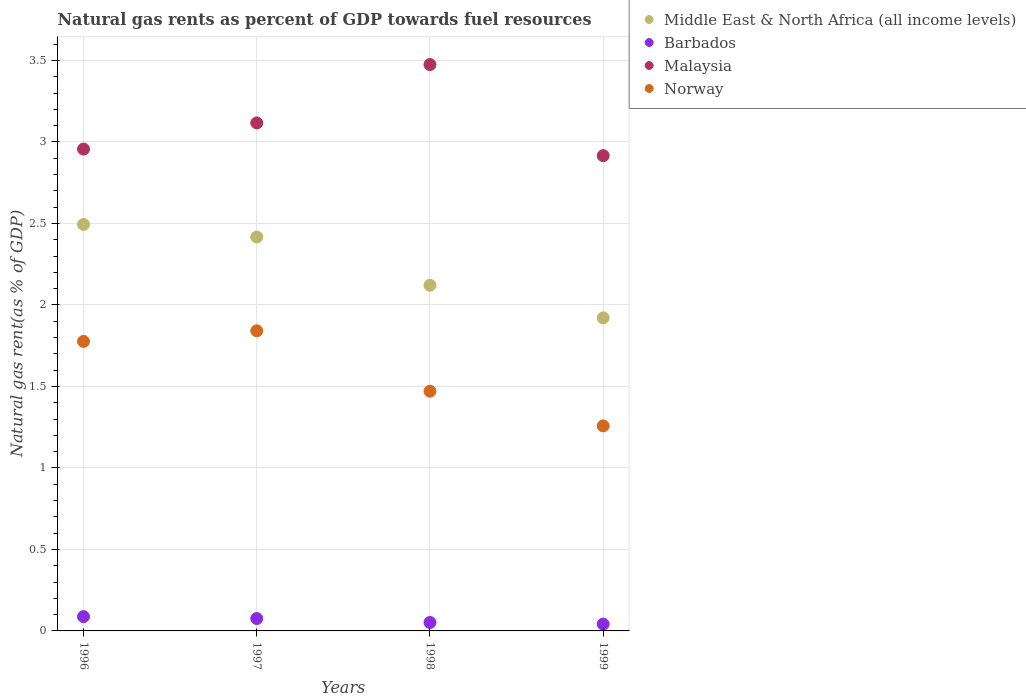Is the number of dotlines equal to the number of legend labels?
Keep it short and to the point. Yes. What is the natural gas rent in Middle East & North Africa (all income levels) in 1998?
Offer a terse response. 2.12. Across all years, what is the maximum natural gas rent in Middle East & North Africa (all income levels)?
Keep it short and to the point. 2.49. Across all years, what is the minimum natural gas rent in Barbados?
Offer a terse response. 0.04. In which year was the natural gas rent in Middle East & North Africa (all income levels) maximum?
Provide a succinct answer. 1996. What is the total natural gas rent in Barbados in the graph?
Your answer should be compact. 0.26. What is the difference between the natural gas rent in Middle East & North Africa (all income levels) in 1996 and that in 1999?
Make the answer very short. 0.57. What is the difference between the natural gas rent in Middle East & North Africa (all income levels) in 1998 and the natural gas rent in Barbados in 1999?
Provide a short and direct response. 2.08. What is the average natural gas rent in Malaysia per year?
Ensure brevity in your answer.  3.12. In the year 1996, what is the difference between the natural gas rent in Middle East & North Africa (all income levels) and natural gas rent in Norway?
Provide a short and direct response. 0.72. What is the ratio of the natural gas rent in Norway in 1998 to that in 1999?
Your answer should be compact. 1.17. Is the natural gas rent in Norway in 1996 less than that in 1998?
Your response must be concise. No. What is the difference between the highest and the second highest natural gas rent in Malaysia?
Ensure brevity in your answer.  0.36. What is the difference between the highest and the lowest natural gas rent in Norway?
Your answer should be very brief. 0.58. Does the natural gas rent in Barbados monotonically increase over the years?
Offer a very short reply. No. Is the natural gas rent in Middle East & North Africa (all income levels) strictly greater than the natural gas rent in Malaysia over the years?
Make the answer very short. No. Is the natural gas rent in Malaysia strictly less than the natural gas rent in Middle East & North Africa (all income levels) over the years?
Ensure brevity in your answer.  No. How many dotlines are there?
Offer a very short reply. 4. How many years are there in the graph?
Provide a short and direct response. 4. What is the difference between two consecutive major ticks on the Y-axis?
Make the answer very short. 0.5. Does the graph contain grids?
Ensure brevity in your answer.  Yes. How many legend labels are there?
Ensure brevity in your answer.  4. What is the title of the graph?
Your response must be concise. Natural gas rents as percent of GDP towards fuel resources. What is the label or title of the X-axis?
Provide a short and direct response. Years. What is the label or title of the Y-axis?
Offer a terse response. Natural gas rent(as % of GDP). What is the Natural gas rent(as % of GDP) in Middle East & North Africa (all income levels) in 1996?
Provide a succinct answer. 2.49. What is the Natural gas rent(as % of GDP) in Barbados in 1996?
Keep it short and to the point. 0.09. What is the Natural gas rent(as % of GDP) in Malaysia in 1996?
Your answer should be very brief. 2.96. What is the Natural gas rent(as % of GDP) in Norway in 1996?
Make the answer very short. 1.78. What is the Natural gas rent(as % of GDP) in Middle East & North Africa (all income levels) in 1997?
Your response must be concise. 2.42. What is the Natural gas rent(as % of GDP) of Barbados in 1997?
Your answer should be very brief. 0.08. What is the Natural gas rent(as % of GDP) of Malaysia in 1997?
Ensure brevity in your answer.  3.12. What is the Natural gas rent(as % of GDP) of Norway in 1997?
Give a very brief answer. 1.84. What is the Natural gas rent(as % of GDP) of Middle East & North Africa (all income levels) in 1998?
Provide a short and direct response. 2.12. What is the Natural gas rent(as % of GDP) of Barbados in 1998?
Offer a very short reply. 0.05. What is the Natural gas rent(as % of GDP) in Malaysia in 1998?
Ensure brevity in your answer.  3.47. What is the Natural gas rent(as % of GDP) of Norway in 1998?
Keep it short and to the point. 1.47. What is the Natural gas rent(as % of GDP) in Middle East & North Africa (all income levels) in 1999?
Keep it short and to the point. 1.92. What is the Natural gas rent(as % of GDP) of Barbados in 1999?
Ensure brevity in your answer.  0.04. What is the Natural gas rent(as % of GDP) of Malaysia in 1999?
Provide a succinct answer. 2.92. What is the Natural gas rent(as % of GDP) in Norway in 1999?
Provide a short and direct response. 1.26. Across all years, what is the maximum Natural gas rent(as % of GDP) in Middle East & North Africa (all income levels)?
Provide a succinct answer. 2.49. Across all years, what is the maximum Natural gas rent(as % of GDP) in Barbados?
Keep it short and to the point. 0.09. Across all years, what is the maximum Natural gas rent(as % of GDP) in Malaysia?
Your answer should be very brief. 3.47. Across all years, what is the maximum Natural gas rent(as % of GDP) of Norway?
Make the answer very short. 1.84. Across all years, what is the minimum Natural gas rent(as % of GDP) of Middle East & North Africa (all income levels)?
Ensure brevity in your answer.  1.92. Across all years, what is the minimum Natural gas rent(as % of GDP) in Barbados?
Give a very brief answer. 0.04. Across all years, what is the minimum Natural gas rent(as % of GDP) of Malaysia?
Ensure brevity in your answer.  2.92. Across all years, what is the minimum Natural gas rent(as % of GDP) of Norway?
Offer a terse response. 1.26. What is the total Natural gas rent(as % of GDP) of Middle East & North Africa (all income levels) in the graph?
Make the answer very short. 8.95. What is the total Natural gas rent(as % of GDP) of Barbados in the graph?
Offer a terse response. 0.26. What is the total Natural gas rent(as % of GDP) of Malaysia in the graph?
Keep it short and to the point. 12.46. What is the total Natural gas rent(as % of GDP) of Norway in the graph?
Ensure brevity in your answer.  6.35. What is the difference between the Natural gas rent(as % of GDP) in Middle East & North Africa (all income levels) in 1996 and that in 1997?
Your response must be concise. 0.08. What is the difference between the Natural gas rent(as % of GDP) of Barbados in 1996 and that in 1997?
Keep it short and to the point. 0.01. What is the difference between the Natural gas rent(as % of GDP) of Malaysia in 1996 and that in 1997?
Ensure brevity in your answer.  -0.16. What is the difference between the Natural gas rent(as % of GDP) in Norway in 1996 and that in 1997?
Provide a succinct answer. -0.07. What is the difference between the Natural gas rent(as % of GDP) of Middle East & North Africa (all income levels) in 1996 and that in 1998?
Make the answer very short. 0.37. What is the difference between the Natural gas rent(as % of GDP) in Barbados in 1996 and that in 1998?
Offer a terse response. 0.04. What is the difference between the Natural gas rent(as % of GDP) of Malaysia in 1996 and that in 1998?
Your answer should be compact. -0.52. What is the difference between the Natural gas rent(as % of GDP) of Norway in 1996 and that in 1998?
Offer a terse response. 0.31. What is the difference between the Natural gas rent(as % of GDP) of Middle East & North Africa (all income levels) in 1996 and that in 1999?
Give a very brief answer. 0.57. What is the difference between the Natural gas rent(as % of GDP) of Barbados in 1996 and that in 1999?
Offer a terse response. 0.05. What is the difference between the Natural gas rent(as % of GDP) of Malaysia in 1996 and that in 1999?
Keep it short and to the point. 0.04. What is the difference between the Natural gas rent(as % of GDP) in Norway in 1996 and that in 1999?
Give a very brief answer. 0.52. What is the difference between the Natural gas rent(as % of GDP) of Middle East & North Africa (all income levels) in 1997 and that in 1998?
Your response must be concise. 0.3. What is the difference between the Natural gas rent(as % of GDP) of Barbados in 1997 and that in 1998?
Your answer should be very brief. 0.02. What is the difference between the Natural gas rent(as % of GDP) of Malaysia in 1997 and that in 1998?
Your answer should be compact. -0.36. What is the difference between the Natural gas rent(as % of GDP) of Norway in 1997 and that in 1998?
Offer a terse response. 0.37. What is the difference between the Natural gas rent(as % of GDP) in Middle East & North Africa (all income levels) in 1997 and that in 1999?
Provide a succinct answer. 0.5. What is the difference between the Natural gas rent(as % of GDP) in Barbados in 1997 and that in 1999?
Ensure brevity in your answer.  0.03. What is the difference between the Natural gas rent(as % of GDP) in Malaysia in 1997 and that in 1999?
Give a very brief answer. 0.2. What is the difference between the Natural gas rent(as % of GDP) of Norway in 1997 and that in 1999?
Provide a short and direct response. 0.58. What is the difference between the Natural gas rent(as % of GDP) in Middle East & North Africa (all income levels) in 1998 and that in 1999?
Offer a terse response. 0.2. What is the difference between the Natural gas rent(as % of GDP) in Barbados in 1998 and that in 1999?
Make the answer very short. 0.01. What is the difference between the Natural gas rent(as % of GDP) of Malaysia in 1998 and that in 1999?
Offer a very short reply. 0.56. What is the difference between the Natural gas rent(as % of GDP) in Norway in 1998 and that in 1999?
Keep it short and to the point. 0.21. What is the difference between the Natural gas rent(as % of GDP) of Middle East & North Africa (all income levels) in 1996 and the Natural gas rent(as % of GDP) of Barbados in 1997?
Offer a very short reply. 2.42. What is the difference between the Natural gas rent(as % of GDP) of Middle East & North Africa (all income levels) in 1996 and the Natural gas rent(as % of GDP) of Malaysia in 1997?
Keep it short and to the point. -0.62. What is the difference between the Natural gas rent(as % of GDP) in Middle East & North Africa (all income levels) in 1996 and the Natural gas rent(as % of GDP) in Norway in 1997?
Your answer should be very brief. 0.65. What is the difference between the Natural gas rent(as % of GDP) of Barbados in 1996 and the Natural gas rent(as % of GDP) of Malaysia in 1997?
Provide a succinct answer. -3.03. What is the difference between the Natural gas rent(as % of GDP) of Barbados in 1996 and the Natural gas rent(as % of GDP) of Norway in 1997?
Your answer should be compact. -1.75. What is the difference between the Natural gas rent(as % of GDP) of Malaysia in 1996 and the Natural gas rent(as % of GDP) of Norway in 1997?
Make the answer very short. 1.11. What is the difference between the Natural gas rent(as % of GDP) of Middle East & North Africa (all income levels) in 1996 and the Natural gas rent(as % of GDP) of Barbados in 1998?
Provide a short and direct response. 2.44. What is the difference between the Natural gas rent(as % of GDP) in Middle East & North Africa (all income levels) in 1996 and the Natural gas rent(as % of GDP) in Malaysia in 1998?
Make the answer very short. -0.98. What is the difference between the Natural gas rent(as % of GDP) of Middle East & North Africa (all income levels) in 1996 and the Natural gas rent(as % of GDP) of Norway in 1998?
Ensure brevity in your answer.  1.02. What is the difference between the Natural gas rent(as % of GDP) in Barbados in 1996 and the Natural gas rent(as % of GDP) in Malaysia in 1998?
Make the answer very short. -3.39. What is the difference between the Natural gas rent(as % of GDP) of Barbados in 1996 and the Natural gas rent(as % of GDP) of Norway in 1998?
Your answer should be very brief. -1.38. What is the difference between the Natural gas rent(as % of GDP) of Malaysia in 1996 and the Natural gas rent(as % of GDP) of Norway in 1998?
Give a very brief answer. 1.49. What is the difference between the Natural gas rent(as % of GDP) in Middle East & North Africa (all income levels) in 1996 and the Natural gas rent(as % of GDP) in Barbados in 1999?
Make the answer very short. 2.45. What is the difference between the Natural gas rent(as % of GDP) in Middle East & North Africa (all income levels) in 1996 and the Natural gas rent(as % of GDP) in Malaysia in 1999?
Provide a short and direct response. -0.42. What is the difference between the Natural gas rent(as % of GDP) in Middle East & North Africa (all income levels) in 1996 and the Natural gas rent(as % of GDP) in Norway in 1999?
Ensure brevity in your answer.  1.24. What is the difference between the Natural gas rent(as % of GDP) of Barbados in 1996 and the Natural gas rent(as % of GDP) of Malaysia in 1999?
Ensure brevity in your answer.  -2.83. What is the difference between the Natural gas rent(as % of GDP) in Barbados in 1996 and the Natural gas rent(as % of GDP) in Norway in 1999?
Your answer should be very brief. -1.17. What is the difference between the Natural gas rent(as % of GDP) of Malaysia in 1996 and the Natural gas rent(as % of GDP) of Norway in 1999?
Offer a very short reply. 1.7. What is the difference between the Natural gas rent(as % of GDP) of Middle East & North Africa (all income levels) in 1997 and the Natural gas rent(as % of GDP) of Barbados in 1998?
Give a very brief answer. 2.37. What is the difference between the Natural gas rent(as % of GDP) of Middle East & North Africa (all income levels) in 1997 and the Natural gas rent(as % of GDP) of Malaysia in 1998?
Your answer should be compact. -1.06. What is the difference between the Natural gas rent(as % of GDP) in Middle East & North Africa (all income levels) in 1997 and the Natural gas rent(as % of GDP) in Norway in 1998?
Provide a succinct answer. 0.95. What is the difference between the Natural gas rent(as % of GDP) of Barbados in 1997 and the Natural gas rent(as % of GDP) of Malaysia in 1998?
Your response must be concise. -3.4. What is the difference between the Natural gas rent(as % of GDP) of Barbados in 1997 and the Natural gas rent(as % of GDP) of Norway in 1998?
Offer a very short reply. -1.39. What is the difference between the Natural gas rent(as % of GDP) in Malaysia in 1997 and the Natural gas rent(as % of GDP) in Norway in 1998?
Ensure brevity in your answer.  1.65. What is the difference between the Natural gas rent(as % of GDP) in Middle East & North Africa (all income levels) in 1997 and the Natural gas rent(as % of GDP) in Barbados in 1999?
Make the answer very short. 2.38. What is the difference between the Natural gas rent(as % of GDP) in Middle East & North Africa (all income levels) in 1997 and the Natural gas rent(as % of GDP) in Malaysia in 1999?
Provide a succinct answer. -0.5. What is the difference between the Natural gas rent(as % of GDP) of Middle East & North Africa (all income levels) in 1997 and the Natural gas rent(as % of GDP) of Norway in 1999?
Provide a short and direct response. 1.16. What is the difference between the Natural gas rent(as % of GDP) of Barbados in 1997 and the Natural gas rent(as % of GDP) of Malaysia in 1999?
Provide a short and direct response. -2.84. What is the difference between the Natural gas rent(as % of GDP) of Barbados in 1997 and the Natural gas rent(as % of GDP) of Norway in 1999?
Your answer should be very brief. -1.18. What is the difference between the Natural gas rent(as % of GDP) of Malaysia in 1997 and the Natural gas rent(as % of GDP) of Norway in 1999?
Keep it short and to the point. 1.86. What is the difference between the Natural gas rent(as % of GDP) of Middle East & North Africa (all income levels) in 1998 and the Natural gas rent(as % of GDP) of Barbados in 1999?
Provide a short and direct response. 2.08. What is the difference between the Natural gas rent(as % of GDP) in Middle East & North Africa (all income levels) in 1998 and the Natural gas rent(as % of GDP) in Malaysia in 1999?
Your answer should be very brief. -0.8. What is the difference between the Natural gas rent(as % of GDP) in Middle East & North Africa (all income levels) in 1998 and the Natural gas rent(as % of GDP) in Norway in 1999?
Offer a terse response. 0.86. What is the difference between the Natural gas rent(as % of GDP) in Barbados in 1998 and the Natural gas rent(as % of GDP) in Malaysia in 1999?
Your response must be concise. -2.86. What is the difference between the Natural gas rent(as % of GDP) in Barbados in 1998 and the Natural gas rent(as % of GDP) in Norway in 1999?
Provide a short and direct response. -1.21. What is the difference between the Natural gas rent(as % of GDP) of Malaysia in 1998 and the Natural gas rent(as % of GDP) of Norway in 1999?
Keep it short and to the point. 2.22. What is the average Natural gas rent(as % of GDP) in Middle East & North Africa (all income levels) per year?
Give a very brief answer. 2.24. What is the average Natural gas rent(as % of GDP) of Barbados per year?
Your response must be concise. 0.06. What is the average Natural gas rent(as % of GDP) in Malaysia per year?
Offer a terse response. 3.12. What is the average Natural gas rent(as % of GDP) of Norway per year?
Offer a terse response. 1.59. In the year 1996, what is the difference between the Natural gas rent(as % of GDP) in Middle East & North Africa (all income levels) and Natural gas rent(as % of GDP) in Barbados?
Your answer should be compact. 2.41. In the year 1996, what is the difference between the Natural gas rent(as % of GDP) in Middle East & North Africa (all income levels) and Natural gas rent(as % of GDP) in Malaysia?
Ensure brevity in your answer.  -0.46. In the year 1996, what is the difference between the Natural gas rent(as % of GDP) in Middle East & North Africa (all income levels) and Natural gas rent(as % of GDP) in Norway?
Provide a succinct answer. 0.72. In the year 1996, what is the difference between the Natural gas rent(as % of GDP) in Barbados and Natural gas rent(as % of GDP) in Malaysia?
Ensure brevity in your answer.  -2.87. In the year 1996, what is the difference between the Natural gas rent(as % of GDP) in Barbados and Natural gas rent(as % of GDP) in Norway?
Offer a very short reply. -1.69. In the year 1996, what is the difference between the Natural gas rent(as % of GDP) in Malaysia and Natural gas rent(as % of GDP) in Norway?
Provide a short and direct response. 1.18. In the year 1997, what is the difference between the Natural gas rent(as % of GDP) of Middle East & North Africa (all income levels) and Natural gas rent(as % of GDP) of Barbados?
Your response must be concise. 2.34. In the year 1997, what is the difference between the Natural gas rent(as % of GDP) in Middle East & North Africa (all income levels) and Natural gas rent(as % of GDP) in Malaysia?
Make the answer very short. -0.7. In the year 1997, what is the difference between the Natural gas rent(as % of GDP) of Middle East & North Africa (all income levels) and Natural gas rent(as % of GDP) of Norway?
Offer a terse response. 0.58. In the year 1997, what is the difference between the Natural gas rent(as % of GDP) in Barbados and Natural gas rent(as % of GDP) in Malaysia?
Make the answer very short. -3.04. In the year 1997, what is the difference between the Natural gas rent(as % of GDP) of Barbados and Natural gas rent(as % of GDP) of Norway?
Provide a short and direct response. -1.77. In the year 1997, what is the difference between the Natural gas rent(as % of GDP) of Malaysia and Natural gas rent(as % of GDP) of Norway?
Provide a succinct answer. 1.28. In the year 1998, what is the difference between the Natural gas rent(as % of GDP) of Middle East & North Africa (all income levels) and Natural gas rent(as % of GDP) of Barbados?
Ensure brevity in your answer.  2.07. In the year 1998, what is the difference between the Natural gas rent(as % of GDP) of Middle East & North Africa (all income levels) and Natural gas rent(as % of GDP) of Malaysia?
Provide a succinct answer. -1.35. In the year 1998, what is the difference between the Natural gas rent(as % of GDP) of Middle East & North Africa (all income levels) and Natural gas rent(as % of GDP) of Norway?
Give a very brief answer. 0.65. In the year 1998, what is the difference between the Natural gas rent(as % of GDP) in Barbados and Natural gas rent(as % of GDP) in Malaysia?
Ensure brevity in your answer.  -3.42. In the year 1998, what is the difference between the Natural gas rent(as % of GDP) of Barbados and Natural gas rent(as % of GDP) of Norway?
Your answer should be very brief. -1.42. In the year 1998, what is the difference between the Natural gas rent(as % of GDP) in Malaysia and Natural gas rent(as % of GDP) in Norway?
Provide a short and direct response. 2. In the year 1999, what is the difference between the Natural gas rent(as % of GDP) in Middle East & North Africa (all income levels) and Natural gas rent(as % of GDP) in Barbados?
Ensure brevity in your answer.  1.88. In the year 1999, what is the difference between the Natural gas rent(as % of GDP) in Middle East & North Africa (all income levels) and Natural gas rent(as % of GDP) in Malaysia?
Make the answer very short. -1. In the year 1999, what is the difference between the Natural gas rent(as % of GDP) in Middle East & North Africa (all income levels) and Natural gas rent(as % of GDP) in Norway?
Offer a very short reply. 0.66. In the year 1999, what is the difference between the Natural gas rent(as % of GDP) in Barbados and Natural gas rent(as % of GDP) in Malaysia?
Give a very brief answer. -2.87. In the year 1999, what is the difference between the Natural gas rent(as % of GDP) in Barbados and Natural gas rent(as % of GDP) in Norway?
Keep it short and to the point. -1.22. In the year 1999, what is the difference between the Natural gas rent(as % of GDP) in Malaysia and Natural gas rent(as % of GDP) in Norway?
Offer a very short reply. 1.66. What is the ratio of the Natural gas rent(as % of GDP) of Middle East & North Africa (all income levels) in 1996 to that in 1997?
Make the answer very short. 1.03. What is the ratio of the Natural gas rent(as % of GDP) of Barbados in 1996 to that in 1997?
Offer a very short reply. 1.16. What is the ratio of the Natural gas rent(as % of GDP) in Malaysia in 1996 to that in 1997?
Provide a short and direct response. 0.95. What is the ratio of the Natural gas rent(as % of GDP) in Norway in 1996 to that in 1997?
Offer a terse response. 0.96. What is the ratio of the Natural gas rent(as % of GDP) of Middle East & North Africa (all income levels) in 1996 to that in 1998?
Give a very brief answer. 1.18. What is the ratio of the Natural gas rent(as % of GDP) of Barbados in 1996 to that in 1998?
Offer a very short reply. 1.7. What is the ratio of the Natural gas rent(as % of GDP) in Malaysia in 1996 to that in 1998?
Your response must be concise. 0.85. What is the ratio of the Natural gas rent(as % of GDP) in Norway in 1996 to that in 1998?
Ensure brevity in your answer.  1.21. What is the ratio of the Natural gas rent(as % of GDP) in Middle East & North Africa (all income levels) in 1996 to that in 1999?
Keep it short and to the point. 1.3. What is the ratio of the Natural gas rent(as % of GDP) of Barbados in 1996 to that in 1999?
Your response must be concise. 2.1. What is the ratio of the Natural gas rent(as % of GDP) in Malaysia in 1996 to that in 1999?
Offer a terse response. 1.01. What is the ratio of the Natural gas rent(as % of GDP) in Norway in 1996 to that in 1999?
Ensure brevity in your answer.  1.41. What is the ratio of the Natural gas rent(as % of GDP) in Middle East & North Africa (all income levels) in 1997 to that in 1998?
Your answer should be very brief. 1.14. What is the ratio of the Natural gas rent(as % of GDP) in Barbados in 1997 to that in 1998?
Offer a very short reply. 1.47. What is the ratio of the Natural gas rent(as % of GDP) in Malaysia in 1997 to that in 1998?
Offer a terse response. 0.9. What is the ratio of the Natural gas rent(as % of GDP) in Norway in 1997 to that in 1998?
Ensure brevity in your answer.  1.25. What is the ratio of the Natural gas rent(as % of GDP) in Middle East & North Africa (all income levels) in 1997 to that in 1999?
Make the answer very short. 1.26. What is the ratio of the Natural gas rent(as % of GDP) of Barbados in 1997 to that in 1999?
Provide a succinct answer. 1.81. What is the ratio of the Natural gas rent(as % of GDP) in Malaysia in 1997 to that in 1999?
Your answer should be very brief. 1.07. What is the ratio of the Natural gas rent(as % of GDP) in Norway in 1997 to that in 1999?
Your response must be concise. 1.46. What is the ratio of the Natural gas rent(as % of GDP) of Middle East & North Africa (all income levels) in 1998 to that in 1999?
Your response must be concise. 1.1. What is the ratio of the Natural gas rent(as % of GDP) in Barbados in 1998 to that in 1999?
Your answer should be compact. 1.24. What is the ratio of the Natural gas rent(as % of GDP) in Malaysia in 1998 to that in 1999?
Give a very brief answer. 1.19. What is the ratio of the Natural gas rent(as % of GDP) in Norway in 1998 to that in 1999?
Ensure brevity in your answer.  1.17. What is the difference between the highest and the second highest Natural gas rent(as % of GDP) of Middle East & North Africa (all income levels)?
Provide a short and direct response. 0.08. What is the difference between the highest and the second highest Natural gas rent(as % of GDP) of Barbados?
Keep it short and to the point. 0.01. What is the difference between the highest and the second highest Natural gas rent(as % of GDP) in Malaysia?
Give a very brief answer. 0.36. What is the difference between the highest and the second highest Natural gas rent(as % of GDP) in Norway?
Keep it short and to the point. 0.07. What is the difference between the highest and the lowest Natural gas rent(as % of GDP) in Middle East & North Africa (all income levels)?
Give a very brief answer. 0.57. What is the difference between the highest and the lowest Natural gas rent(as % of GDP) in Barbados?
Make the answer very short. 0.05. What is the difference between the highest and the lowest Natural gas rent(as % of GDP) in Malaysia?
Your answer should be very brief. 0.56. What is the difference between the highest and the lowest Natural gas rent(as % of GDP) in Norway?
Provide a short and direct response. 0.58. 